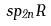Convert formula to latex. <formula><loc_0><loc_0><loc_500><loc_500>s p _ { 2 n } R</formula> 